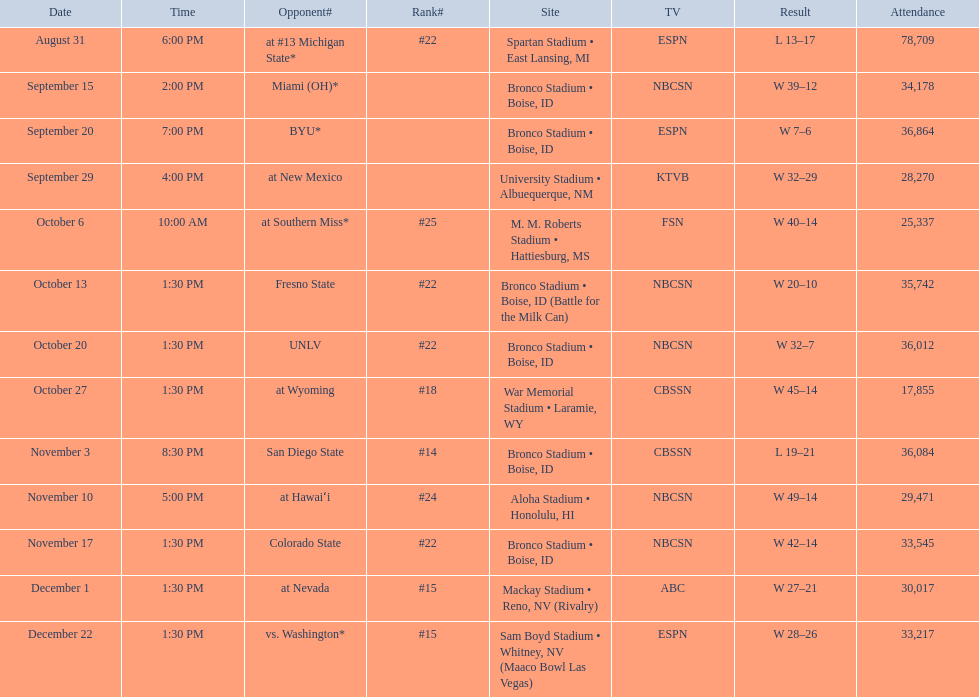After competing against unlv, who were the broncos' next opponents? Wyoming. 